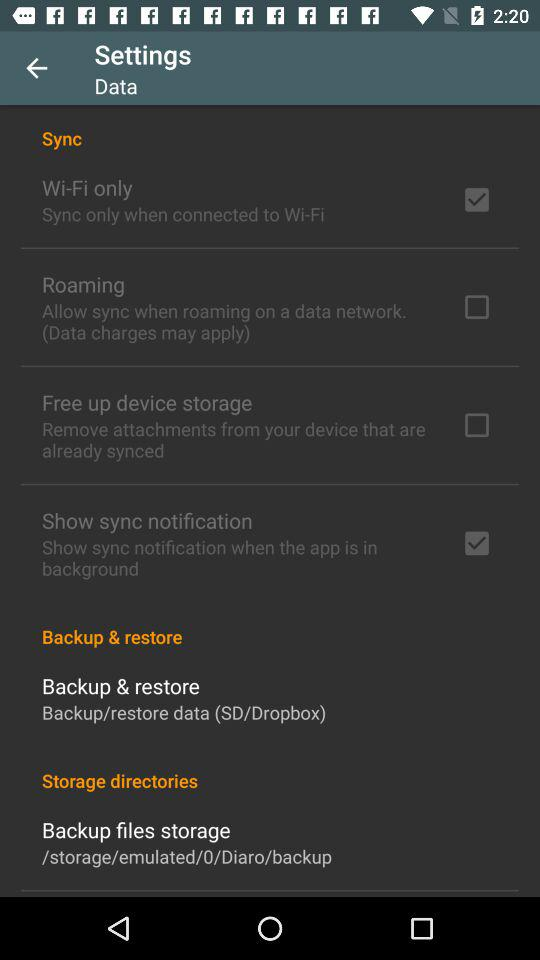How many sync options are available?
Answer the question using a single word or phrase. 4 